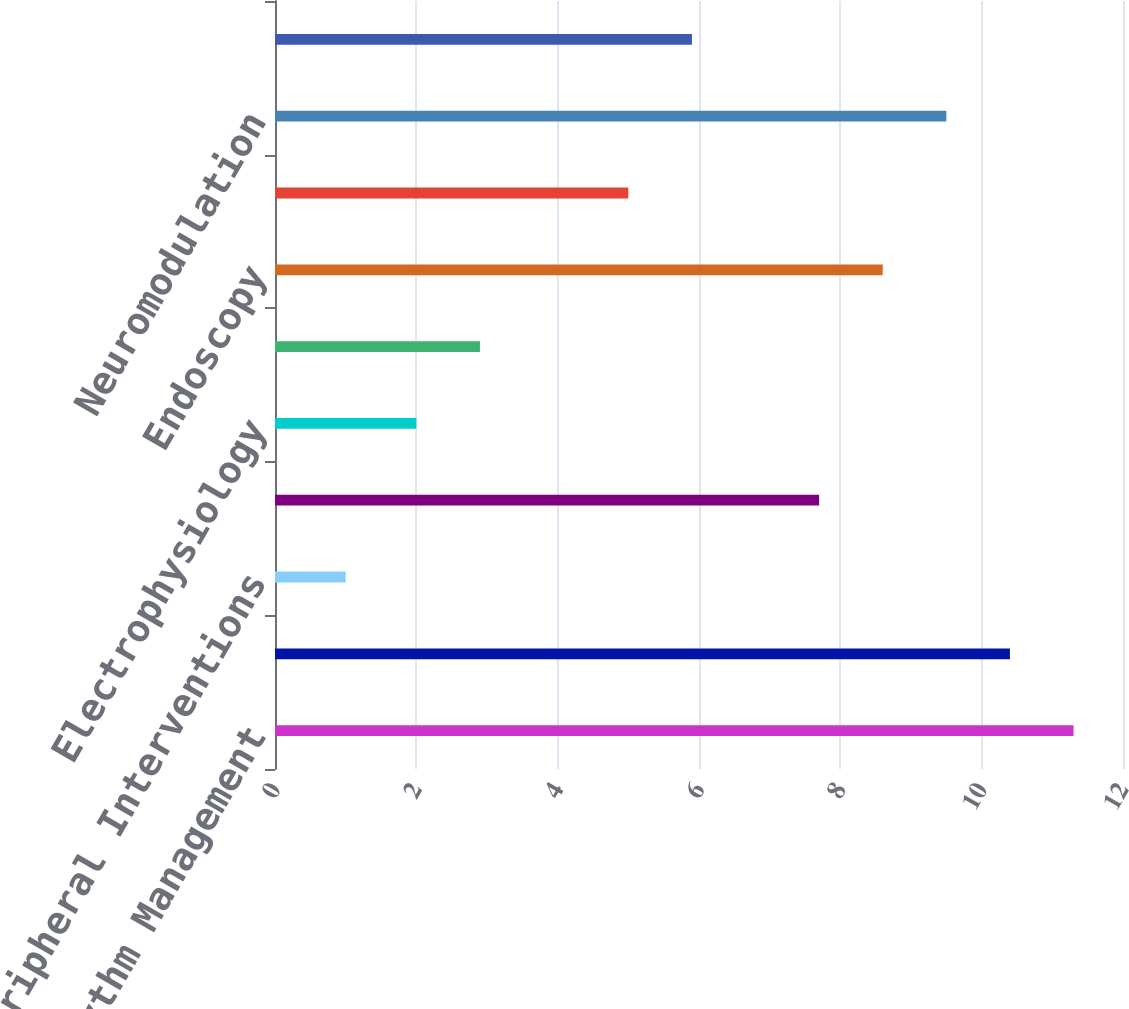Convert chart to OTSL. <chart><loc_0><loc_0><loc_500><loc_500><bar_chart><fcel>Cardiac Rhythm Management<fcel>Interventional Cardiology<fcel>Peripheral Interventions<fcel>Cardiovascular Group<fcel>Electrophysiology<fcel>Neurovascular<fcel>Endoscopy<fcel>Urology/Women's Health<fcel>Neuromodulation<fcel>Subtotal<nl><fcel>11.3<fcel>10.4<fcel>1<fcel>7.7<fcel>2<fcel>2.9<fcel>8.6<fcel>5<fcel>9.5<fcel>5.9<nl></chart> 